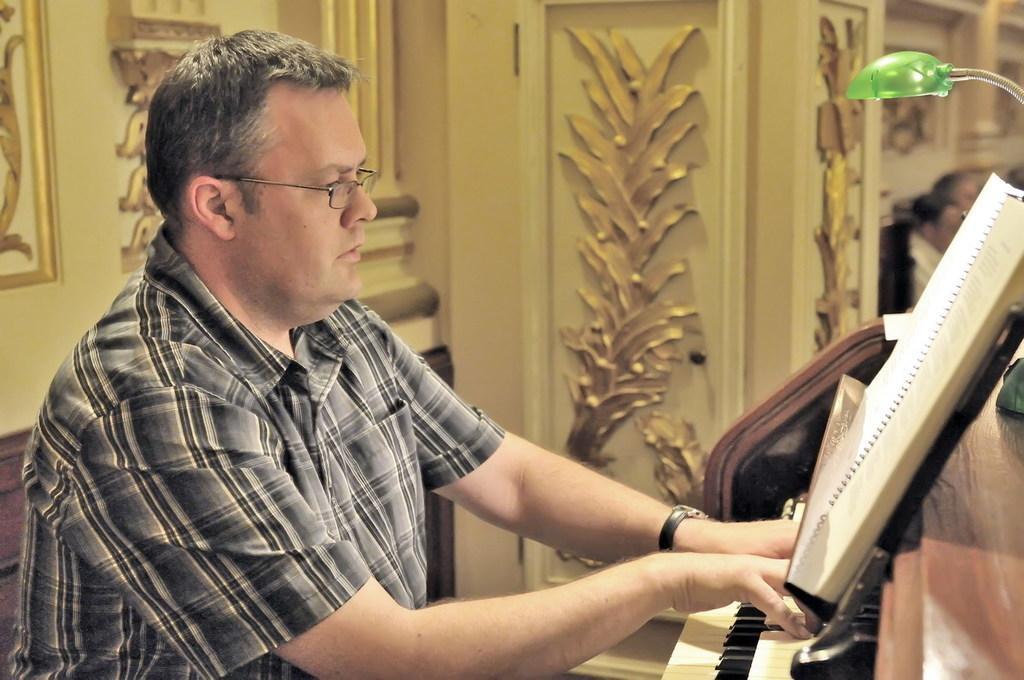Can you describe this image briefly? The person is sitting and playing piano and there is a book in front of him. 